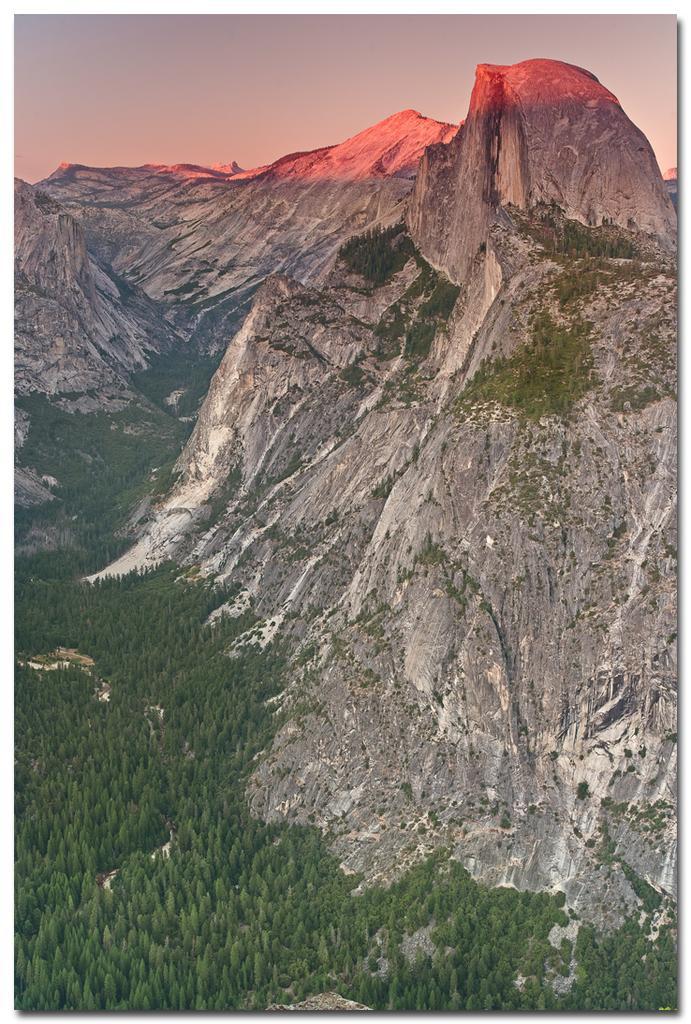How would you summarize this image in a sentence or two? In this picture I can see hills and trees and a cloudy sky. 